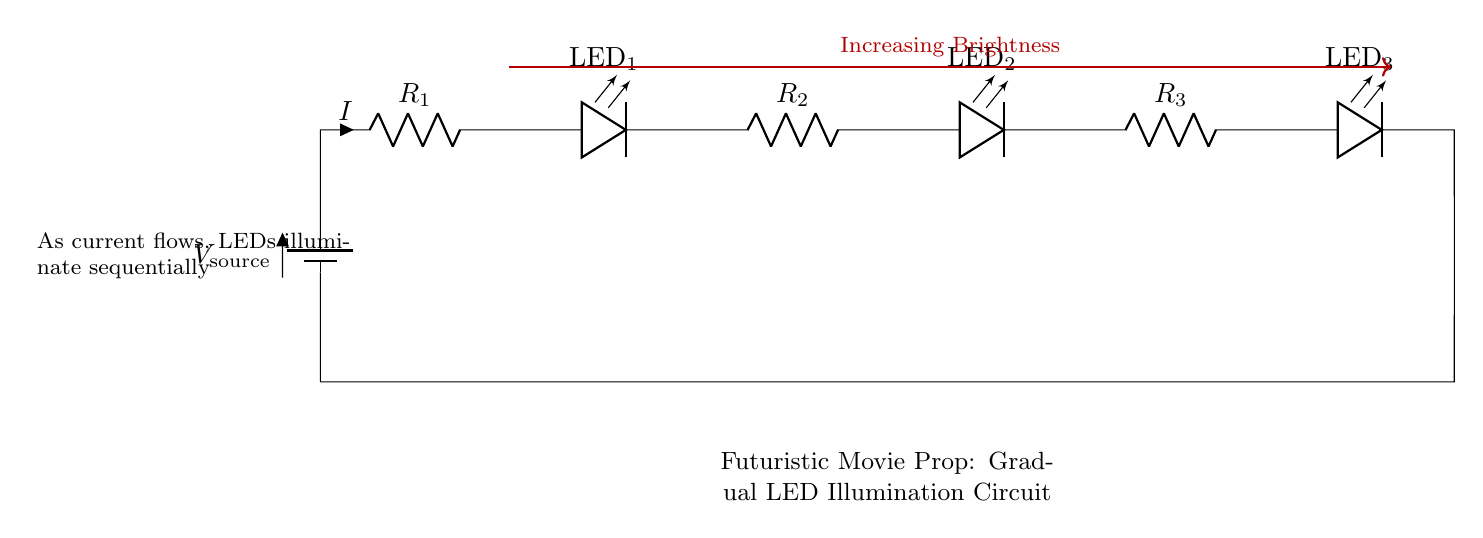What is the power source in this circuit? The circuit uses a battery as its power source, which is indicated at the beginning of the circuit with the label V_source.
Answer: Battery How many resistors are present in the circuit? Counting the components in the diagram, there are three resistors labeled R_1, R_2, and R_3.
Answer: Three What happens to the brightness of the LEDs as more current flows? According to the diagram, it indicates that the brightness of the LEDs increases as current flows through the circuit, lighting them sequentially.
Answer: Increasing Brightness What is the total number of LEDs in this circuit? The diagram shows a total of three LEDs labeled LED_1, LED_2, and LED_3, wired in series.
Answer: Three Which component controls the current flow in this circuit? The resistors, labeled R_1, R_2, and R_3, control the current flowing through the circuit by limiting it, which is crucial for the operation of the LEDs.
Answer: Resistors If one LED fails, what is the expected outcome for the other LEDs in series? In a series circuit, if one LED fails, the circuit is broken, and all subsequent LEDs will not light up because the current cannot flow.
Answer: No illumination 